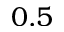<formula> <loc_0><loc_0><loc_500><loc_500>0 . 5</formula> 